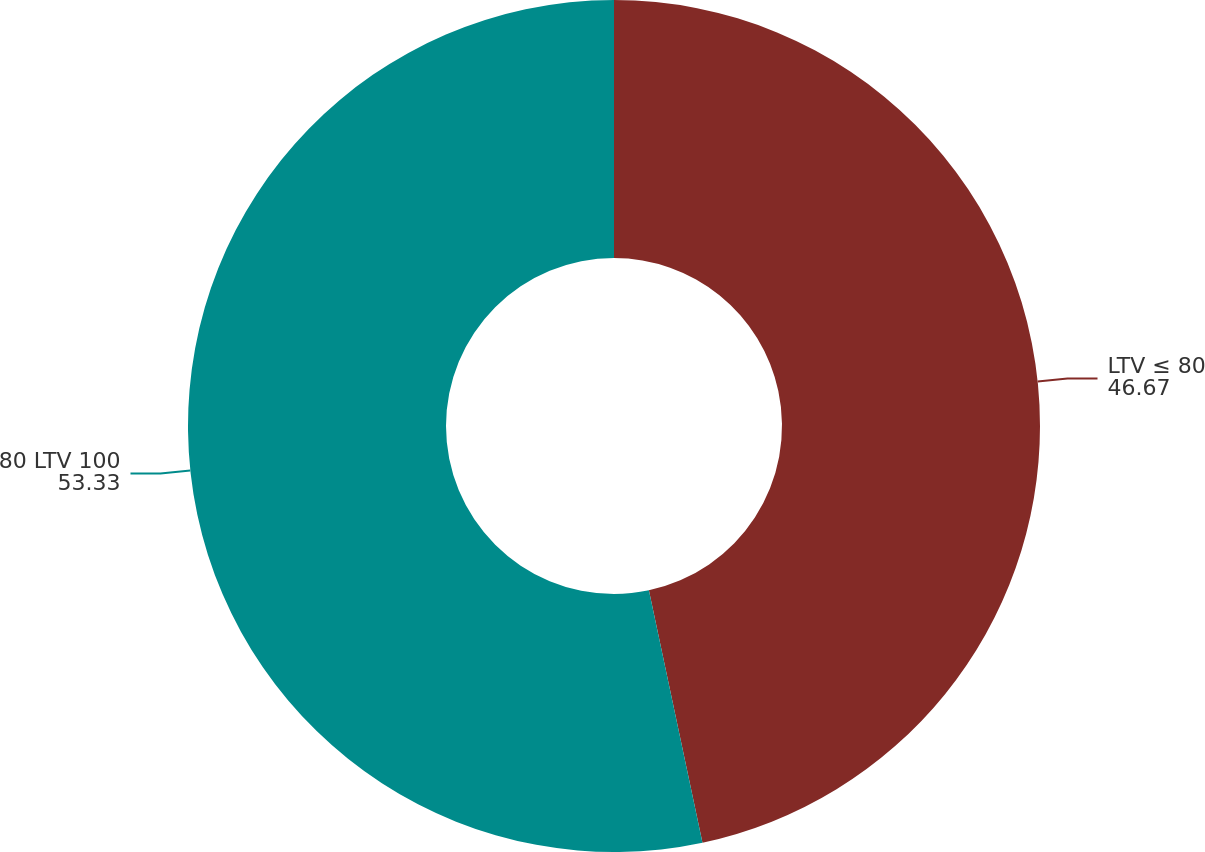Convert chart. <chart><loc_0><loc_0><loc_500><loc_500><pie_chart><fcel>LTV ≤ 80<fcel>80 LTV 100<nl><fcel>46.67%<fcel>53.33%<nl></chart> 